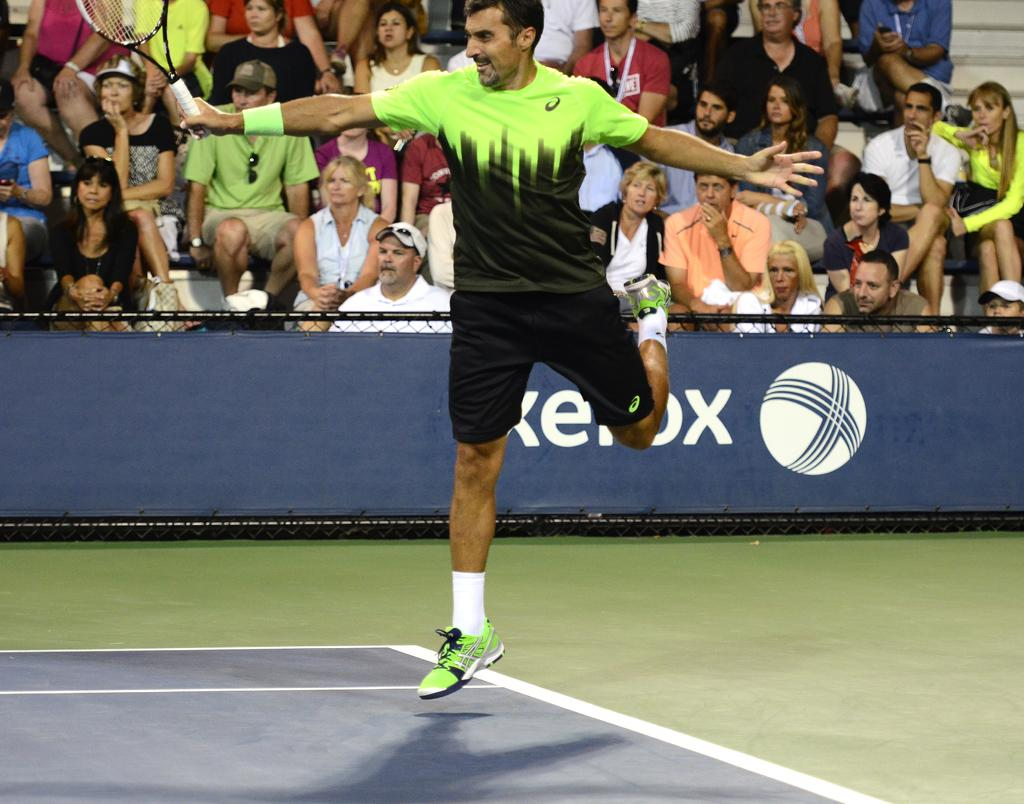Who is the main subject in the image? There is a person in the image. What is the person holding in the image? The person is holding a bat. What can be seen in the background of the image? There is an audience in the background of the image. What are the people in the audience doing? The audience is watching the person playing the game. What type of tomatoes can be seen growing in the image? There are no tomatoes present in the image. What is the purpose of the tiger in the image? There is no tiger present in the image, so it does not have a purpose in the context of the image. 